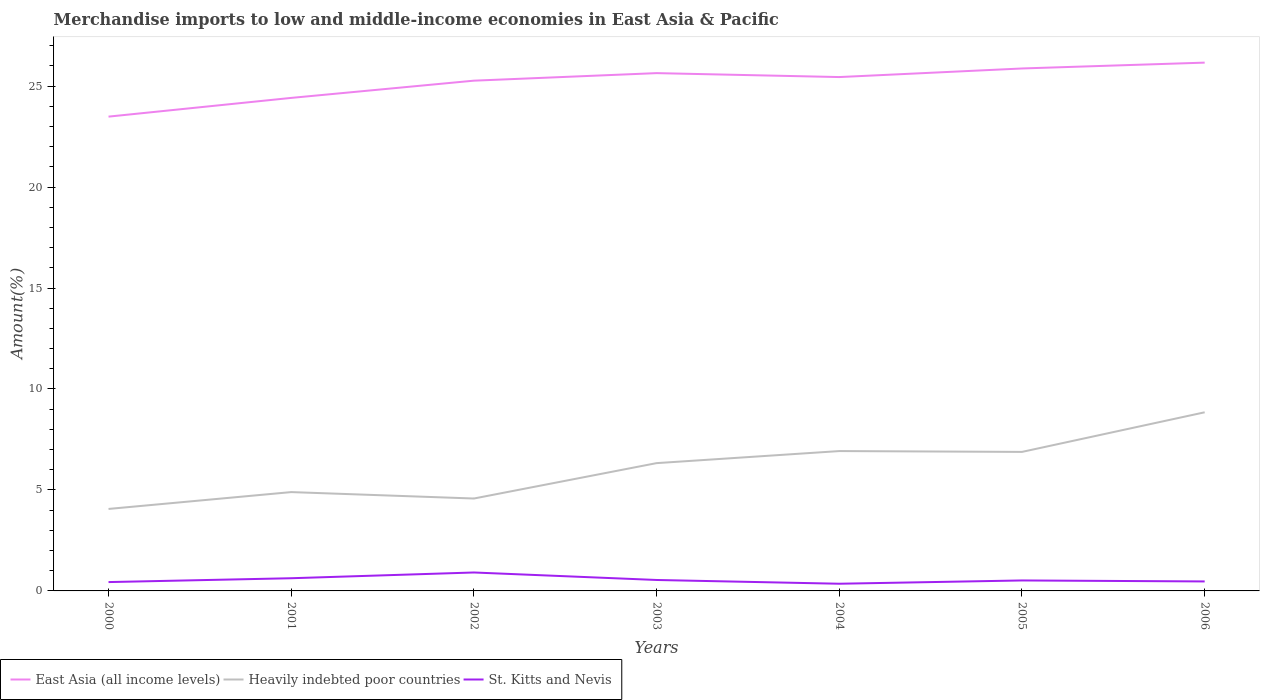Across all years, what is the maximum percentage of amount earned from merchandise imports in St. Kitts and Nevis?
Offer a terse response. 0.36. In which year was the percentage of amount earned from merchandise imports in St. Kitts and Nevis maximum?
Offer a very short reply. 2004. What is the total percentage of amount earned from merchandise imports in Heavily indebted poor countries in the graph?
Give a very brief answer. -0.83. What is the difference between the highest and the second highest percentage of amount earned from merchandise imports in East Asia (all income levels)?
Ensure brevity in your answer.  2.67. How many lines are there?
Offer a very short reply. 3. How many years are there in the graph?
Keep it short and to the point. 7. Does the graph contain grids?
Give a very brief answer. No. How many legend labels are there?
Provide a short and direct response. 3. What is the title of the graph?
Offer a terse response. Merchandise imports to low and middle-income economies in East Asia & Pacific. What is the label or title of the Y-axis?
Ensure brevity in your answer.  Amount(%). What is the Amount(%) of East Asia (all income levels) in 2000?
Provide a short and direct response. 23.49. What is the Amount(%) in Heavily indebted poor countries in 2000?
Provide a succinct answer. 4.06. What is the Amount(%) in St. Kitts and Nevis in 2000?
Give a very brief answer. 0.44. What is the Amount(%) in East Asia (all income levels) in 2001?
Ensure brevity in your answer.  24.41. What is the Amount(%) in Heavily indebted poor countries in 2001?
Offer a terse response. 4.89. What is the Amount(%) in St. Kitts and Nevis in 2001?
Ensure brevity in your answer.  0.63. What is the Amount(%) of East Asia (all income levels) in 2002?
Your response must be concise. 25.27. What is the Amount(%) in Heavily indebted poor countries in 2002?
Your answer should be compact. 4.58. What is the Amount(%) of St. Kitts and Nevis in 2002?
Your response must be concise. 0.91. What is the Amount(%) in East Asia (all income levels) in 2003?
Give a very brief answer. 25.64. What is the Amount(%) in Heavily indebted poor countries in 2003?
Make the answer very short. 6.33. What is the Amount(%) of St. Kitts and Nevis in 2003?
Offer a very short reply. 0.54. What is the Amount(%) in East Asia (all income levels) in 2004?
Offer a terse response. 25.45. What is the Amount(%) of Heavily indebted poor countries in 2004?
Make the answer very short. 6.93. What is the Amount(%) in St. Kitts and Nevis in 2004?
Offer a very short reply. 0.36. What is the Amount(%) in East Asia (all income levels) in 2005?
Give a very brief answer. 25.87. What is the Amount(%) in Heavily indebted poor countries in 2005?
Your answer should be very brief. 6.88. What is the Amount(%) in St. Kitts and Nevis in 2005?
Offer a terse response. 0.52. What is the Amount(%) of East Asia (all income levels) in 2006?
Your response must be concise. 26.16. What is the Amount(%) in Heavily indebted poor countries in 2006?
Give a very brief answer. 8.85. What is the Amount(%) of St. Kitts and Nevis in 2006?
Your answer should be very brief. 0.47. Across all years, what is the maximum Amount(%) in East Asia (all income levels)?
Offer a terse response. 26.16. Across all years, what is the maximum Amount(%) in Heavily indebted poor countries?
Your answer should be compact. 8.85. Across all years, what is the maximum Amount(%) in St. Kitts and Nevis?
Your answer should be very brief. 0.91. Across all years, what is the minimum Amount(%) in East Asia (all income levels)?
Give a very brief answer. 23.49. Across all years, what is the minimum Amount(%) of Heavily indebted poor countries?
Your answer should be compact. 4.06. Across all years, what is the minimum Amount(%) of St. Kitts and Nevis?
Ensure brevity in your answer.  0.36. What is the total Amount(%) in East Asia (all income levels) in the graph?
Offer a very short reply. 176.29. What is the total Amount(%) in Heavily indebted poor countries in the graph?
Give a very brief answer. 42.51. What is the total Amount(%) of St. Kitts and Nevis in the graph?
Ensure brevity in your answer.  3.86. What is the difference between the Amount(%) in East Asia (all income levels) in 2000 and that in 2001?
Your answer should be very brief. -0.93. What is the difference between the Amount(%) of Heavily indebted poor countries in 2000 and that in 2001?
Make the answer very short. -0.83. What is the difference between the Amount(%) in St. Kitts and Nevis in 2000 and that in 2001?
Ensure brevity in your answer.  -0.19. What is the difference between the Amount(%) in East Asia (all income levels) in 2000 and that in 2002?
Give a very brief answer. -1.78. What is the difference between the Amount(%) in Heavily indebted poor countries in 2000 and that in 2002?
Your answer should be very brief. -0.52. What is the difference between the Amount(%) of St. Kitts and Nevis in 2000 and that in 2002?
Ensure brevity in your answer.  -0.47. What is the difference between the Amount(%) of East Asia (all income levels) in 2000 and that in 2003?
Ensure brevity in your answer.  -2.15. What is the difference between the Amount(%) in Heavily indebted poor countries in 2000 and that in 2003?
Your answer should be compact. -2.27. What is the difference between the Amount(%) of St. Kitts and Nevis in 2000 and that in 2003?
Your response must be concise. -0.1. What is the difference between the Amount(%) of East Asia (all income levels) in 2000 and that in 2004?
Offer a terse response. -1.96. What is the difference between the Amount(%) in Heavily indebted poor countries in 2000 and that in 2004?
Keep it short and to the point. -2.87. What is the difference between the Amount(%) in St. Kitts and Nevis in 2000 and that in 2004?
Ensure brevity in your answer.  0.08. What is the difference between the Amount(%) in East Asia (all income levels) in 2000 and that in 2005?
Your response must be concise. -2.38. What is the difference between the Amount(%) of Heavily indebted poor countries in 2000 and that in 2005?
Give a very brief answer. -2.82. What is the difference between the Amount(%) in St. Kitts and Nevis in 2000 and that in 2005?
Provide a short and direct response. -0.08. What is the difference between the Amount(%) of East Asia (all income levels) in 2000 and that in 2006?
Provide a succinct answer. -2.67. What is the difference between the Amount(%) in Heavily indebted poor countries in 2000 and that in 2006?
Your answer should be compact. -4.79. What is the difference between the Amount(%) of St. Kitts and Nevis in 2000 and that in 2006?
Offer a very short reply. -0.03. What is the difference between the Amount(%) of East Asia (all income levels) in 2001 and that in 2002?
Your answer should be compact. -0.85. What is the difference between the Amount(%) in Heavily indebted poor countries in 2001 and that in 2002?
Provide a short and direct response. 0.32. What is the difference between the Amount(%) in St. Kitts and Nevis in 2001 and that in 2002?
Your response must be concise. -0.28. What is the difference between the Amount(%) in East Asia (all income levels) in 2001 and that in 2003?
Make the answer very short. -1.23. What is the difference between the Amount(%) of Heavily indebted poor countries in 2001 and that in 2003?
Give a very brief answer. -1.43. What is the difference between the Amount(%) of St. Kitts and Nevis in 2001 and that in 2003?
Provide a short and direct response. 0.09. What is the difference between the Amount(%) in East Asia (all income levels) in 2001 and that in 2004?
Ensure brevity in your answer.  -1.03. What is the difference between the Amount(%) of Heavily indebted poor countries in 2001 and that in 2004?
Offer a very short reply. -2.03. What is the difference between the Amount(%) of St. Kitts and Nevis in 2001 and that in 2004?
Ensure brevity in your answer.  0.27. What is the difference between the Amount(%) in East Asia (all income levels) in 2001 and that in 2005?
Keep it short and to the point. -1.46. What is the difference between the Amount(%) of Heavily indebted poor countries in 2001 and that in 2005?
Keep it short and to the point. -1.99. What is the difference between the Amount(%) in St. Kitts and Nevis in 2001 and that in 2005?
Keep it short and to the point. 0.11. What is the difference between the Amount(%) in East Asia (all income levels) in 2001 and that in 2006?
Keep it short and to the point. -1.75. What is the difference between the Amount(%) in Heavily indebted poor countries in 2001 and that in 2006?
Give a very brief answer. -3.95. What is the difference between the Amount(%) in St. Kitts and Nevis in 2001 and that in 2006?
Provide a succinct answer. 0.16. What is the difference between the Amount(%) of East Asia (all income levels) in 2002 and that in 2003?
Ensure brevity in your answer.  -0.37. What is the difference between the Amount(%) of Heavily indebted poor countries in 2002 and that in 2003?
Provide a short and direct response. -1.75. What is the difference between the Amount(%) in St. Kitts and Nevis in 2002 and that in 2003?
Ensure brevity in your answer.  0.37. What is the difference between the Amount(%) of East Asia (all income levels) in 2002 and that in 2004?
Ensure brevity in your answer.  -0.18. What is the difference between the Amount(%) in Heavily indebted poor countries in 2002 and that in 2004?
Give a very brief answer. -2.35. What is the difference between the Amount(%) of St. Kitts and Nevis in 2002 and that in 2004?
Offer a very short reply. 0.56. What is the difference between the Amount(%) in East Asia (all income levels) in 2002 and that in 2005?
Give a very brief answer. -0.6. What is the difference between the Amount(%) in Heavily indebted poor countries in 2002 and that in 2005?
Provide a succinct answer. -2.31. What is the difference between the Amount(%) of St. Kitts and Nevis in 2002 and that in 2005?
Keep it short and to the point. 0.39. What is the difference between the Amount(%) in East Asia (all income levels) in 2002 and that in 2006?
Provide a succinct answer. -0.89. What is the difference between the Amount(%) in Heavily indebted poor countries in 2002 and that in 2006?
Provide a succinct answer. -4.27. What is the difference between the Amount(%) of St. Kitts and Nevis in 2002 and that in 2006?
Offer a very short reply. 0.44. What is the difference between the Amount(%) of East Asia (all income levels) in 2003 and that in 2004?
Make the answer very short. 0.2. What is the difference between the Amount(%) in Heavily indebted poor countries in 2003 and that in 2004?
Ensure brevity in your answer.  -0.6. What is the difference between the Amount(%) in St. Kitts and Nevis in 2003 and that in 2004?
Offer a terse response. 0.19. What is the difference between the Amount(%) in East Asia (all income levels) in 2003 and that in 2005?
Offer a terse response. -0.23. What is the difference between the Amount(%) of Heavily indebted poor countries in 2003 and that in 2005?
Give a very brief answer. -0.56. What is the difference between the Amount(%) in St. Kitts and Nevis in 2003 and that in 2005?
Provide a succinct answer. 0.02. What is the difference between the Amount(%) of East Asia (all income levels) in 2003 and that in 2006?
Provide a short and direct response. -0.52. What is the difference between the Amount(%) of Heavily indebted poor countries in 2003 and that in 2006?
Your answer should be very brief. -2.52. What is the difference between the Amount(%) of St. Kitts and Nevis in 2003 and that in 2006?
Your answer should be very brief. 0.07. What is the difference between the Amount(%) of East Asia (all income levels) in 2004 and that in 2005?
Offer a terse response. -0.43. What is the difference between the Amount(%) in Heavily indebted poor countries in 2004 and that in 2005?
Make the answer very short. 0.04. What is the difference between the Amount(%) in St. Kitts and Nevis in 2004 and that in 2005?
Make the answer very short. -0.16. What is the difference between the Amount(%) of East Asia (all income levels) in 2004 and that in 2006?
Ensure brevity in your answer.  -0.71. What is the difference between the Amount(%) in Heavily indebted poor countries in 2004 and that in 2006?
Offer a terse response. -1.92. What is the difference between the Amount(%) in St. Kitts and Nevis in 2004 and that in 2006?
Your answer should be very brief. -0.11. What is the difference between the Amount(%) in East Asia (all income levels) in 2005 and that in 2006?
Your answer should be very brief. -0.29. What is the difference between the Amount(%) in Heavily indebted poor countries in 2005 and that in 2006?
Give a very brief answer. -1.96. What is the difference between the Amount(%) of St. Kitts and Nevis in 2005 and that in 2006?
Keep it short and to the point. 0.05. What is the difference between the Amount(%) of East Asia (all income levels) in 2000 and the Amount(%) of Heavily indebted poor countries in 2001?
Keep it short and to the point. 18.59. What is the difference between the Amount(%) in East Asia (all income levels) in 2000 and the Amount(%) in St. Kitts and Nevis in 2001?
Ensure brevity in your answer.  22.86. What is the difference between the Amount(%) in Heavily indebted poor countries in 2000 and the Amount(%) in St. Kitts and Nevis in 2001?
Give a very brief answer. 3.43. What is the difference between the Amount(%) of East Asia (all income levels) in 2000 and the Amount(%) of Heavily indebted poor countries in 2002?
Ensure brevity in your answer.  18.91. What is the difference between the Amount(%) of East Asia (all income levels) in 2000 and the Amount(%) of St. Kitts and Nevis in 2002?
Provide a short and direct response. 22.57. What is the difference between the Amount(%) of Heavily indebted poor countries in 2000 and the Amount(%) of St. Kitts and Nevis in 2002?
Offer a terse response. 3.15. What is the difference between the Amount(%) in East Asia (all income levels) in 2000 and the Amount(%) in Heavily indebted poor countries in 2003?
Offer a terse response. 17.16. What is the difference between the Amount(%) in East Asia (all income levels) in 2000 and the Amount(%) in St. Kitts and Nevis in 2003?
Make the answer very short. 22.95. What is the difference between the Amount(%) of Heavily indebted poor countries in 2000 and the Amount(%) of St. Kitts and Nevis in 2003?
Provide a short and direct response. 3.52. What is the difference between the Amount(%) in East Asia (all income levels) in 2000 and the Amount(%) in Heavily indebted poor countries in 2004?
Provide a succinct answer. 16.56. What is the difference between the Amount(%) of East Asia (all income levels) in 2000 and the Amount(%) of St. Kitts and Nevis in 2004?
Offer a terse response. 23.13. What is the difference between the Amount(%) of Heavily indebted poor countries in 2000 and the Amount(%) of St. Kitts and Nevis in 2004?
Your response must be concise. 3.7. What is the difference between the Amount(%) in East Asia (all income levels) in 2000 and the Amount(%) in Heavily indebted poor countries in 2005?
Ensure brevity in your answer.  16.6. What is the difference between the Amount(%) in East Asia (all income levels) in 2000 and the Amount(%) in St. Kitts and Nevis in 2005?
Provide a succinct answer. 22.97. What is the difference between the Amount(%) of Heavily indebted poor countries in 2000 and the Amount(%) of St. Kitts and Nevis in 2005?
Offer a terse response. 3.54. What is the difference between the Amount(%) of East Asia (all income levels) in 2000 and the Amount(%) of Heavily indebted poor countries in 2006?
Ensure brevity in your answer.  14.64. What is the difference between the Amount(%) of East Asia (all income levels) in 2000 and the Amount(%) of St. Kitts and Nevis in 2006?
Provide a short and direct response. 23.02. What is the difference between the Amount(%) in Heavily indebted poor countries in 2000 and the Amount(%) in St. Kitts and Nevis in 2006?
Give a very brief answer. 3.59. What is the difference between the Amount(%) in East Asia (all income levels) in 2001 and the Amount(%) in Heavily indebted poor countries in 2002?
Your response must be concise. 19.84. What is the difference between the Amount(%) in East Asia (all income levels) in 2001 and the Amount(%) in St. Kitts and Nevis in 2002?
Give a very brief answer. 23.5. What is the difference between the Amount(%) of Heavily indebted poor countries in 2001 and the Amount(%) of St. Kitts and Nevis in 2002?
Your answer should be very brief. 3.98. What is the difference between the Amount(%) of East Asia (all income levels) in 2001 and the Amount(%) of Heavily indebted poor countries in 2003?
Give a very brief answer. 18.09. What is the difference between the Amount(%) of East Asia (all income levels) in 2001 and the Amount(%) of St. Kitts and Nevis in 2003?
Make the answer very short. 23.87. What is the difference between the Amount(%) of Heavily indebted poor countries in 2001 and the Amount(%) of St. Kitts and Nevis in 2003?
Make the answer very short. 4.35. What is the difference between the Amount(%) in East Asia (all income levels) in 2001 and the Amount(%) in Heavily indebted poor countries in 2004?
Your response must be concise. 17.49. What is the difference between the Amount(%) in East Asia (all income levels) in 2001 and the Amount(%) in St. Kitts and Nevis in 2004?
Ensure brevity in your answer.  24.06. What is the difference between the Amount(%) of Heavily indebted poor countries in 2001 and the Amount(%) of St. Kitts and Nevis in 2004?
Give a very brief answer. 4.54. What is the difference between the Amount(%) of East Asia (all income levels) in 2001 and the Amount(%) of Heavily indebted poor countries in 2005?
Your answer should be very brief. 17.53. What is the difference between the Amount(%) in East Asia (all income levels) in 2001 and the Amount(%) in St. Kitts and Nevis in 2005?
Ensure brevity in your answer.  23.9. What is the difference between the Amount(%) of Heavily indebted poor countries in 2001 and the Amount(%) of St. Kitts and Nevis in 2005?
Your answer should be compact. 4.38. What is the difference between the Amount(%) of East Asia (all income levels) in 2001 and the Amount(%) of Heavily indebted poor countries in 2006?
Your response must be concise. 15.57. What is the difference between the Amount(%) of East Asia (all income levels) in 2001 and the Amount(%) of St. Kitts and Nevis in 2006?
Make the answer very short. 23.95. What is the difference between the Amount(%) of Heavily indebted poor countries in 2001 and the Amount(%) of St. Kitts and Nevis in 2006?
Offer a very short reply. 4.42. What is the difference between the Amount(%) in East Asia (all income levels) in 2002 and the Amount(%) in Heavily indebted poor countries in 2003?
Offer a terse response. 18.94. What is the difference between the Amount(%) of East Asia (all income levels) in 2002 and the Amount(%) of St. Kitts and Nevis in 2003?
Offer a very short reply. 24.73. What is the difference between the Amount(%) in Heavily indebted poor countries in 2002 and the Amount(%) in St. Kitts and Nevis in 2003?
Your answer should be compact. 4.03. What is the difference between the Amount(%) of East Asia (all income levels) in 2002 and the Amount(%) of Heavily indebted poor countries in 2004?
Ensure brevity in your answer.  18.34. What is the difference between the Amount(%) of East Asia (all income levels) in 2002 and the Amount(%) of St. Kitts and Nevis in 2004?
Offer a terse response. 24.91. What is the difference between the Amount(%) of Heavily indebted poor countries in 2002 and the Amount(%) of St. Kitts and Nevis in 2004?
Your answer should be compact. 4.22. What is the difference between the Amount(%) of East Asia (all income levels) in 2002 and the Amount(%) of Heavily indebted poor countries in 2005?
Provide a succinct answer. 18.38. What is the difference between the Amount(%) of East Asia (all income levels) in 2002 and the Amount(%) of St. Kitts and Nevis in 2005?
Offer a terse response. 24.75. What is the difference between the Amount(%) of Heavily indebted poor countries in 2002 and the Amount(%) of St. Kitts and Nevis in 2005?
Your response must be concise. 4.06. What is the difference between the Amount(%) of East Asia (all income levels) in 2002 and the Amount(%) of Heavily indebted poor countries in 2006?
Offer a very short reply. 16.42. What is the difference between the Amount(%) in East Asia (all income levels) in 2002 and the Amount(%) in St. Kitts and Nevis in 2006?
Offer a very short reply. 24.8. What is the difference between the Amount(%) in Heavily indebted poor countries in 2002 and the Amount(%) in St. Kitts and Nevis in 2006?
Offer a very short reply. 4.11. What is the difference between the Amount(%) of East Asia (all income levels) in 2003 and the Amount(%) of Heavily indebted poor countries in 2004?
Provide a succinct answer. 18.72. What is the difference between the Amount(%) in East Asia (all income levels) in 2003 and the Amount(%) in St. Kitts and Nevis in 2004?
Provide a short and direct response. 25.29. What is the difference between the Amount(%) of Heavily indebted poor countries in 2003 and the Amount(%) of St. Kitts and Nevis in 2004?
Make the answer very short. 5.97. What is the difference between the Amount(%) in East Asia (all income levels) in 2003 and the Amount(%) in Heavily indebted poor countries in 2005?
Your answer should be very brief. 18.76. What is the difference between the Amount(%) of East Asia (all income levels) in 2003 and the Amount(%) of St. Kitts and Nevis in 2005?
Give a very brief answer. 25.12. What is the difference between the Amount(%) of Heavily indebted poor countries in 2003 and the Amount(%) of St. Kitts and Nevis in 2005?
Keep it short and to the point. 5.81. What is the difference between the Amount(%) of East Asia (all income levels) in 2003 and the Amount(%) of Heavily indebted poor countries in 2006?
Your answer should be very brief. 16.8. What is the difference between the Amount(%) of East Asia (all income levels) in 2003 and the Amount(%) of St. Kitts and Nevis in 2006?
Your answer should be compact. 25.17. What is the difference between the Amount(%) in Heavily indebted poor countries in 2003 and the Amount(%) in St. Kitts and Nevis in 2006?
Your response must be concise. 5.86. What is the difference between the Amount(%) of East Asia (all income levels) in 2004 and the Amount(%) of Heavily indebted poor countries in 2005?
Keep it short and to the point. 18.56. What is the difference between the Amount(%) of East Asia (all income levels) in 2004 and the Amount(%) of St. Kitts and Nevis in 2005?
Offer a very short reply. 24.93. What is the difference between the Amount(%) in Heavily indebted poor countries in 2004 and the Amount(%) in St. Kitts and Nevis in 2005?
Provide a succinct answer. 6.41. What is the difference between the Amount(%) in East Asia (all income levels) in 2004 and the Amount(%) in Heavily indebted poor countries in 2006?
Your answer should be very brief. 16.6. What is the difference between the Amount(%) in East Asia (all income levels) in 2004 and the Amount(%) in St. Kitts and Nevis in 2006?
Your answer should be very brief. 24.98. What is the difference between the Amount(%) of Heavily indebted poor countries in 2004 and the Amount(%) of St. Kitts and Nevis in 2006?
Provide a succinct answer. 6.46. What is the difference between the Amount(%) of East Asia (all income levels) in 2005 and the Amount(%) of Heavily indebted poor countries in 2006?
Provide a succinct answer. 17.03. What is the difference between the Amount(%) in East Asia (all income levels) in 2005 and the Amount(%) in St. Kitts and Nevis in 2006?
Give a very brief answer. 25.4. What is the difference between the Amount(%) of Heavily indebted poor countries in 2005 and the Amount(%) of St. Kitts and Nevis in 2006?
Offer a terse response. 6.42. What is the average Amount(%) of East Asia (all income levels) per year?
Your response must be concise. 25.18. What is the average Amount(%) in Heavily indebted poor countries per year?
Your response must be concise. 6.07. What is the average Amount(%) of St. Kitts and Nevis per year?
Provide a succinct answer. 0.55. In the year 2000, what is the difference between the Amount(%) in East Asia (all income levels) and Amount(%) in Heavily indebted poor countries?
Offer a very short reply. 19.43. In the year 2000, what is the difference between the Amount(%) of East Asia (all income levels) and Amount(%) of St. Kitts and Nevis?
Your answer should be very brief. 23.05. In the year 2000, what is the difference between the Amount(%) of Heavily indebted poor countries and Amount(%) of St. Kitts and Nevis?
Provide a short and direct response. 3.62. In the year 2001, what is the difference between the Amount(%) in East Asia (all income levels) and Amount(%) in Heavily indebted poor countries?
Offer a very short reply. 19.52. In the year 2001, what is the difference between the Amount(%) in East Asia (all income levels) and Amount(%) in St. Kitts and Nevis?
Make the answer very short. 23.79. In the year 2001, what is the difference between the Amount(%) in Heavily indebted poor countries and Amount(%) in St. Kitts and Nevis?
Give a very brief answer. 4.27. In the year 2002, what is the difference between the Amount(%) of East Asia (all income levels) and Amount(%) of Heavily indebted poor countries?
Your answer should be compact. 20.69. In the year 2002, what is the difference between the Amount(%) of East Asia (all income levels) and Amount(%) of St. Kitts and Nevis?
Make the answer very short. 24.36. In the year 2002, what is the difference between the Amount(%) of Heavily indebted poor countries and Amount(%) of St. Kitts and Nevis?
Your answer should be compact. 3.66. In the year 2003, what is the difference between the Amount(%) in East Asia (all income levels) and Amount(%) in Heavily indebted poor countries?
Your response must be concise. 19.31. In the year 2003, what is the difference between the Amount(%) of East Asia (all income levels) and Amount(%) of St. Kitts and Nevis?
Keep it short and to the point. 25.1. In the year 2003, what is the difference between the Amount(%) of Heavily indebted poor countries and Amount(%) of St. Kitts and Nevis?
Keep it short and to the point. 5.79. In the year 2004, what is the difference between the Amount(%) of East Asia (all income levels) and Amount(%) of Heavily indebted poor countries?
Ensure brevity in your answer.  18.52. In the year 2004, what is the difference between the Amount(%) in East Asia (all income levels) and Amount(%) in St. Kitts and Nevis?
Provide a succinct answer. 25.09. In the year 2004, what is the difference between the Amount(%) in Heavily indebted poor countries and Amount(%) in St. Kitts and Nevis?
Make the answer very short. 6.57. In the year 2005, what is the difference between the Amount(%) of East Asia (all income levels) and Amount(%) of Heavily indebted poor countries?
Offer a terse response. 18.99. In the year 2005, what is the difference between the Amount(%) in East Asia (all income levels) and Amount(%) in St. Kitts and Nevis?
Give a very brief answer. 25.35. In the year 2005, what is the difference between the Amount(%) in Heavily indebted poor countries and Amount(%) in St. Kitts and Nevis?
Keep it short and to the point. 6.37. In the year 2006, what is the difference between the Amount(%) of East Asia (all income levels) and Amount(%) of Heavily indebted poor countries?
Your answer should be very brief. 17.31. In the year 2006, what is the difference between the Amount(%) in East Asia (all income levels) and Amount(%) in St. Kitts and Nevis?
Offer a very short reply. 25.69. In the year 2006, what is the difference between the Amount(%) in Heavily indebted poor countries and Amount(%) in St. Kitts and Nevis?
Provide a succinct answer. 8.38. What is the ratio of the Amount(%) of East Asia (all income levels) in 2000 to that in 2001?
Make the answer very short. 0.96. What is the ratio of the Amount(%) of Heavily indebted poor countries in 2000 to that in 2001?
Your answer should be very brief. 0.83. What is the ratio of the Amount(%) of St. Kitts and Nevis in 2000 to that in 2001?
Ensure brevity in your answer.  0.7. What is the ratio of the Amount(%) of East Asia (all income levels) in 2000 to that in 2002?
Make the answer very short. 0.93. What is the ratio of the Amount(%) of Heavily indebted poor countries in 2000 to that in 2002?
Provide a short and direct response. 0.89. What is the ratio of the Amount(%) of St. Kitts and Nevis in 2000 to that in 2002?
Provide a short and direct response. 0.48. What is the ratio of the Amount(%) in East Asia (all income levels) in 2000 to that in 2003?
Offer a terse response. 0.92. What is the ratio of the Amount(%) in Heavily indebted poor countries in 2000 to that in 2003?
Make the answer very short. 0.64. What is the ratio of the Amount(%) of St. Kitts and Nevis in 2000 to that in 2003?
Offer a very short reply. 0.81. What is the ratio of the Amount(%) of East Asia (all income levels) in 2000 to that in 2004?
Provide a short and direct response. 0.92. What is the ratio of the Amount(%) of Heavily indebted poor countries in 2000 to that in 2004?
Provide a short and direct response. 0.59. What is the ratio of the Amount(%) in St. Kitts and Nevis in 2000 to that in 2004?
Give a very brief answer. 1.23. What is the ratio of the Amount(%) in East Asia (all income levels) in 2000 to that in 2005?
Your response must be concise. 0.91. What is the ratio of the Amount(%) of Heavily indebted poor countries in 2000 to that in 2005?
Offer a very short reply. 0.59. What is the ratio of the Amount(%) of St. Kitts and Nevis in 2000 to that in 2005?
Provide a succinct answer. 0.84. What is the ratio of the Amount(%) in East Asia (all income levels) in 2000 to that in 2006?
Keep it short and to the point. 0.9. What is the ratio of the Amount(%) of Heavily indebted poor countries in 2000 to that in 2006?
Offer a very short reply. 0.46. What is the ratio of the Amount(%) in St. Kitts and Nevis in 2000 to that in 2006?
Offer a very short reply. 0.93. What is the ratio of the Amount(%) of East Asia (all income levels) in 2001 to that in 2002?
Provide a succinct answer. 0.97. What is the ratio of the Amount(%) in Heavily indebted poor countries in 2001 to that in 2002?
Make the answer very short. 1.07. What is the ratio of the Amount(%) in St. Kitts and Nevis in 2001 to that in 2002?
Offer a very short reply. 0.69. What is the ratio of the Amount(%) in East Asia (all income levels) in 2001 to that in 2003?
Offer a terse response. 0.95. What is the ratio of the Amount(%) of Heavily indebted poor countries in 2001 to that in 2003?
Keep it short and to the point. 0.77. What is the ratio of the Amount(%) of St. Kitts and Nevis in 2001 to that in 2003?
Your response must be concise. 1.16. What is the ratio of the Amount(%) in East Asia (all income levels) in 2001 to that in 2004?
Provide a succinct answer. 0.96. What is the ratio of the Amount(%) in Heavily indebted poor countries in 2001 to that in 2004?
Give a very brief answer. 0.71. What is the ratio of the Amount(%) in St. Kitts and Nevis in 2001 to that in 2004?
Keep it short and to the point. 1.77. What is the ratio of the Amount(%) of East Asia (all income levels) in 2001 to that in 2005?
Your response must be concise. 0.94. What is the ratio of the Amount(%) in Heavily indebted poor countries in 2001 to that in 2005?
Provide a short and direct response. 0.71. What is the ratio of the Amount(%) in St. Kitts and Nevis in 2001 to that in 2005?
Give a very brief answer. 1.21. What is the ratio of the Amount(%) of East Asia (all income levels) in 2001 to that in 2006?
Provide a succinct answer. 0.93. What is the ratio of the Amount(%) of Heavily indebted poor countries in 2001 to that in 2006?
Ensure brevity in your answer.  0.55. What is the ratio of the Amount(%) of St. Kitts and Nevis in 2001 to that in 2006?
Your answer should be very brief. 1.34. What is the ratio of the Amount(%) in East Asia (all income levels) in 2002 to that in 2003?
Provide a short and direct response. 0.99. What is the ratio of the Amount(%) in Heavily indebted poor countries in 2002 to that in 2003?
Ensure brevity in your answer.  0.72. What is the ratio of the Amount(%) of St. Kitts and Nevis in 2002 to that in 2003?
Your response must be concise. 1.68. What is the ratio of the Amount(%) of East Asia (all income levels) in 2002 to that in 2004?
Your response must be concise. 0.99. What is the ratio of the Amount(%) of Heavily indebted poor countries in 2002 to that in 2004?
Offer a very short reply. 0.66. What is the ratio of the Amount(%) of St. Kitts and Nevis in 2002 to that in 2004?
Ensure brevity in your answer.  2.56. What is the ratio of the Amount(%) of East Asia (all income levels) in 2002 to that in 2005?
Ensure brevity in your answer.  0.98. What is the ratio of the Amount(%) of Heavily indebted poor countries in 2002 to that in 2005?
Your answer should be very brief. 0.66. What is the ratio of the Amount(%) in St. Kitts and Nevis in 2002 to that in 2005?
Offer a terse response. 1.76. What is the ratio of the Amount(%) of East Asia (all income levels) in 2002 to that in 2006?
Provide a short and direct response. 0.97. What is the ratio of the Amount(%) of Heavily indebted poor countries in 2002 to that in 2006?
Your answer should be compact. 0.52. What is the ratio of the Amount(%) of St. Kitts and Nevis in 2002 to that in 2006?
Ensure brevity in your answer.  1.95. What is the ratio of the Amount(%) of East Asia (all income levels) in 2003 to that in 2004?
Ensure brevity in your answer.  1.01. What is the ratio of the Amount(%) of Heavily indebted poor countries in 2003 to that in 2004?
Make the answer very short. 0.91. What is the ratio of the Amount(%) in St. Kitts and Nevis in 2003 to that in 2004?
Your response must be concise. 1.52. What is the ratio of the Amount(%) of Heavily indebted poor countries in 2003 to that in 2005?
Ensure brevity in your answer.  0.92. What is the ratio of the Amount(%) of St. Kitts and Nevis in 2003 to that in 2005?
Ensure brevity in your answer.  1.05. What is the ratio of the Amount(%) in East Asia (all income levels) in 2003 to that in 2006?
Provide a short and direct response. 0.98. What is the ratio of the Amount(%) in Heavily indebted poor countries in 2003 to that in 2006?
Your answer should be very brief. 0.72. What is the ratio of the Amount(%) of St. Kitts and Nevis in 2003 to that in 2006?
Your response must be concise. 1.15. What is the ratio of the Amount(%) in East Asia (all income levels) in 2004 to that in 2005?
Offer a terse response. 0.98. What is the ratio of the Amount(%) in St. Kitts and Nevis in 2004 to that in 2005?
Your answer should be compact. 0.69. What is the ratio of the Amount(%) in East Asia (all income levels) in 2004 to that in 2006?
Provide a short and direct response. 0.97. What is the ratio of the Amount(%) of Heavily indebted poor countries in 2004 to that in 2006?
Give a very brief answer. 0.78. What is the ratio of the Amount(%) in St. Kitts and Nevis in 2004 to that in 2006?
Give a very brief answer. 0.76. What is the ratio of the Amount(%) in East Asia (all income levels) in 2005 to that in 2006?
Ensure brevity in your answer.  0.99. What is the ratio of the Amount(%) of Heavily indebted poor countries in 2005 to that in 2006?
Your answer should be very brief. 0.78. What is the ratio of the Amount(%) in St. Kitts and Nevis in 2005 to that in 2006?
Give a very brief answer. 1.1. What is the difference between the highest and the second highest Amount(%) in East Asia (all income levels)?
Your answer should be very brief. 0.29. What is the difference between the highest and the second highest Amount(%) in Heavily indebted poor countries?
Provide a succinct answer. 1.92. What is the difference between the highest and the second highest Amount(%) in St. Kitts and Nevis?
Offer a terse response. 0.28. What is the difference between the highest and the lowest Amount(%) of East Asia (all income levels)?
Give a very brief answer. 2.67. What is the difference between the highest and the lowest Amount(%) of Heavily indebted poor countries?
Ensure brevity in your answer.  4.79. What is the difference between the highest and the lowest Amount(%) of St. Kitts and Nevis?
Provide a succinct answer. 0.56. 